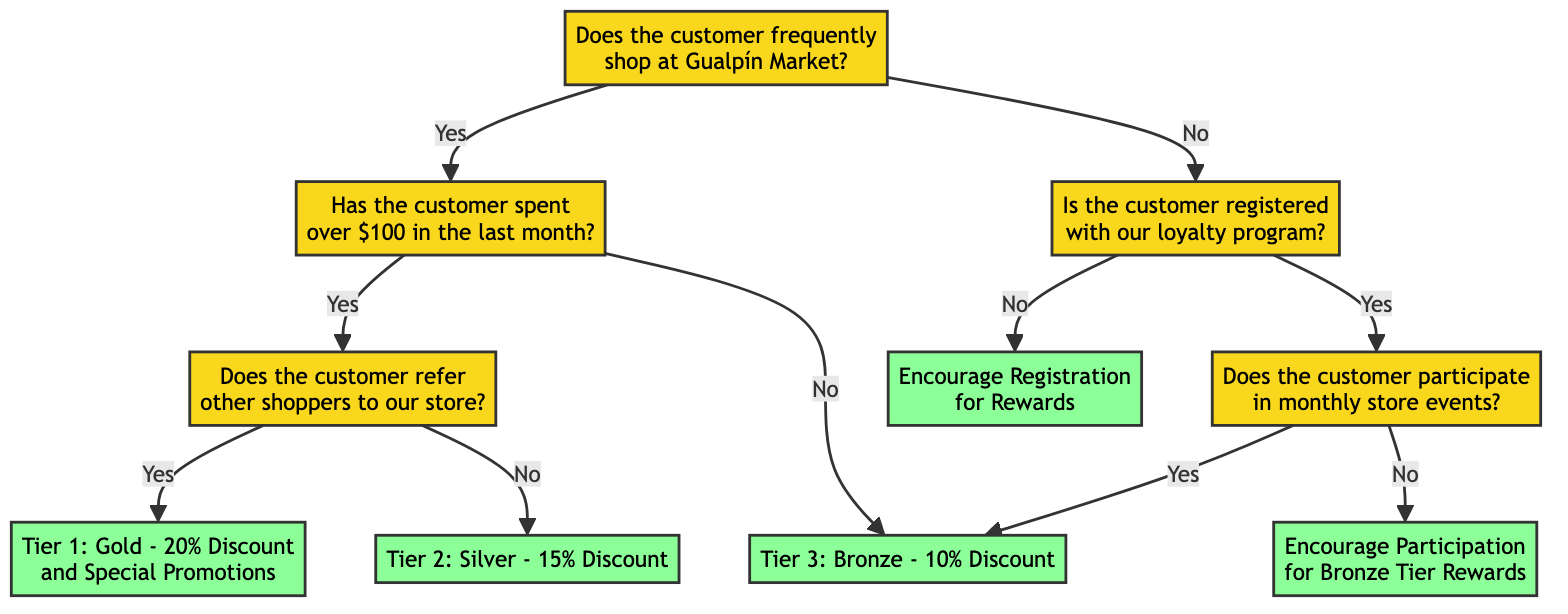What is the first question in the decision tree? The first question in the decision tree is about whether the customer frequently shops at Gualpín Market. This can be identified by looking at the starting node of the diagram.
Answer: Does the customer frequently shop at Gualpín Market? What happens if a customer spends over $100? If a customer spends over $100, the decision tree leads to a further question about whether the customer refers other shoppers to the store. This follows the path from the "frequent shopper yes" node down to the next question.
Answer: Does the customer refer other shoppers to our store? How many discount tiers are in the decision tree? The decision tree has three discount tiers: Gold, Silver, and Bronze. This information can be gathered by counting the distinct result nodes that describe the tiers.
Answer: Three What is the outcome for a customer who does not participate in monthly store events but is registered with the loyalty program? For a customer who is registered but does not participate in events, the outcome directs to encouraging participation to achieve Bronze tier rewards. This follows the path from "registered yes" to "participates_in_events no."
Answer: Encourage Participation for Bronze Tier Rewards What discount does a frequent shopper who does not refer other shoppers receive? A frequent shopper who does not refer other shoppers is placed in Tier 2 and receives a 15% discount. This is derived from navigating through the questions of the decision tree starting from frequent shopper yes to the no outcome in the referral question.
Answer: Tier 2: Silver - 15% Discount How does the loyalty program encourage registration? The loyalty program encourages registration for customers who are not currently registered, as indicated by the path leading from the "registered no" node to the result. This reflects a strategy to increase participation in the loyalty program.
Answer: Encourage Registration for Rewards What is the outcome if a customer frequently shops but has not spent more than $100? If a customer frequently shops but has not spent more than $100, they are placed in Tier 3, which offers a 10% discount. This can be traced through the decision tree from the frequent shopper yes to the over 100 no result.
Answer: Tier 3: Bronze - 10% Discount What is the pathway for a customer who does not frequently shop and is not registered? The pathway leads directly to encouraging registration for rewards, as there are no further questions for customers who both do not frequently shop and are not registered in the program.
Answer: Encourage Registration for Rewards What happens if a customer frequently shops, spends over $100, but does not participate in monthly events? In this case, the customer would receive a 10% discount, which falls into Tier 3, despite spending over $100 since participation in events is a separate condition. This can be followed through the flow from the initial question to the final result.
Answer: Tier 3: Bronze - 10% Discount 